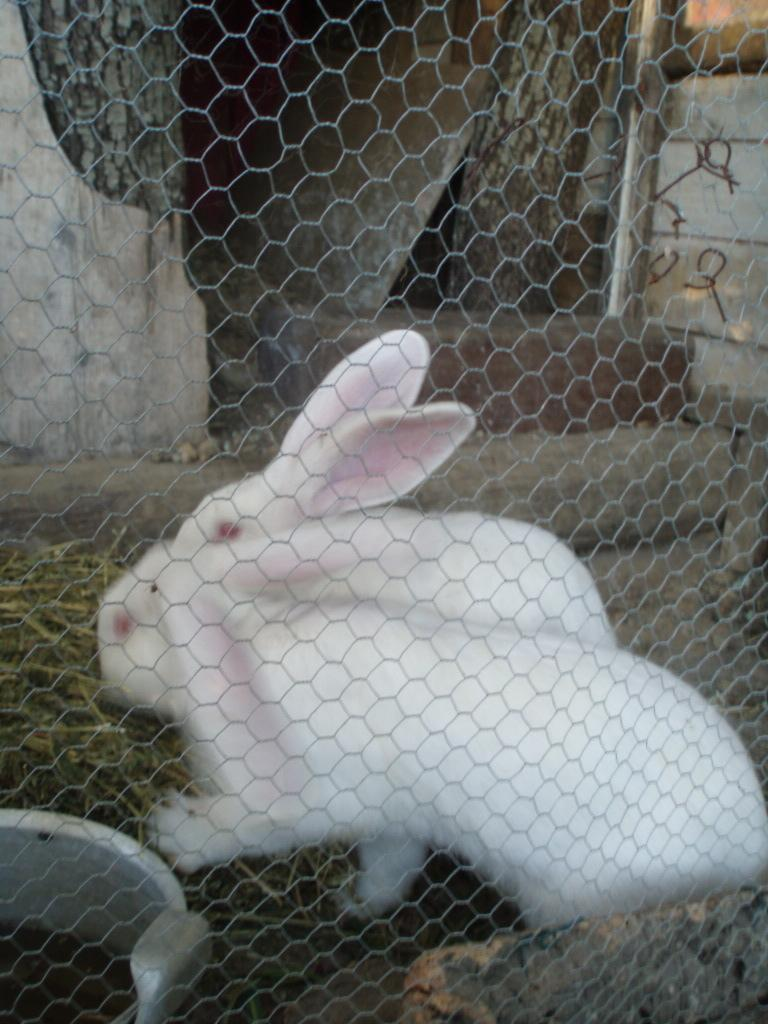What type of animals are present in the image? There are rabbits in the image. What type of vegetation is visible in the image? There is grass in the image. How are the rabbits and grass visible in the image? The rabbits and grass are visible through a mesh. How many women are visible in the image? There are no women present in the image; it features rabbits and grass visible through a mesh. 